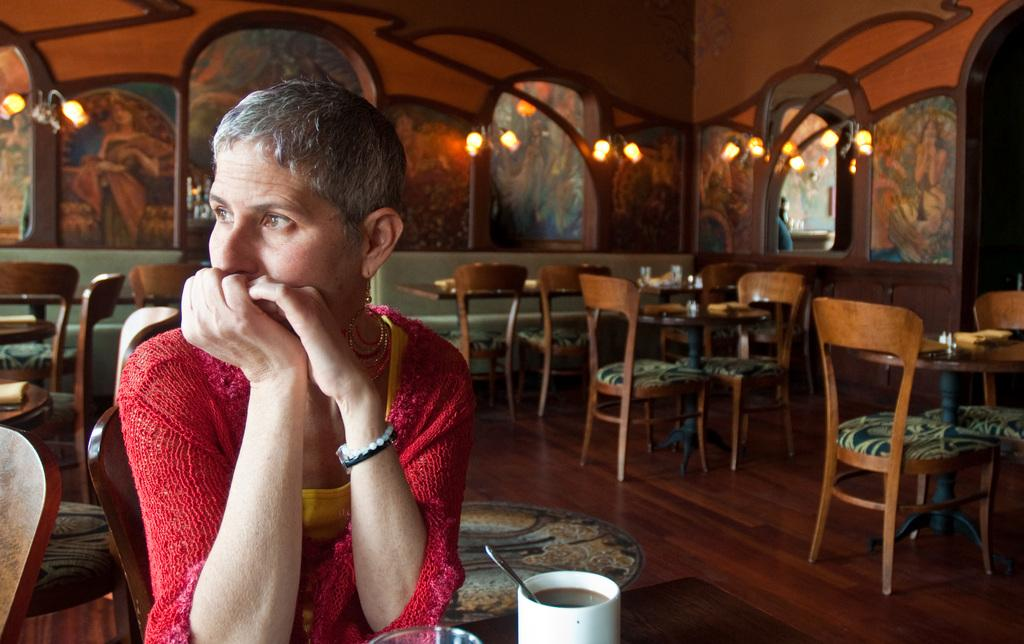What is the person in the image doing? The person is sitting on a chair. What objects are on the table in the image? There is a cup and a glass on the table. How many chairs are visible in the image? There are chairs in the image. What can be seen in the background of the image? There is a wall and lights in the background. What part of the room is visible in the image? The floor is visible in the image. Can you see the person's toe in the image? There is no indication of the person's toe in the image. Is there is a turkey present in the image? No, there is no turkey present in the image. 